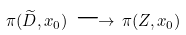Convert formula to latex. <formula><loc_0><loc_0><loc_500><loc_500>\pi ( \widetilde { D } , x _ { 0 } ) \, \longrightarrow \, \pi ( Z , x _ { 0 } )</formula> 